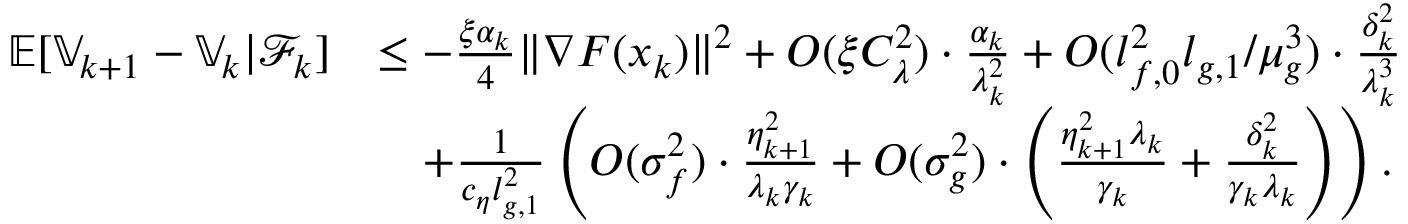<formula> <loc_0><loc_0><loc_500><loc_500>\begin{array} { r l } { \mathbb { E } [ \mathbb { V } _ { k + 1 } - \mathbb { V } _ { k } | \mathcal { F } _ { k } ] } & { \leq - \frac { \xi \alpha _ { k } } { 4 } \| \nabla F ( x _ { k } ) \| ^ { 2 } + O ( \xi C _ { \lambda } ^ { 2 } ) \cdot \frac { \alpha _ { k } } { \lambda _ { k } ^ { 2 } } + O ( l _ { f , 0 } ^ { 2 } l _ { g , 1 } / \mu _ { g } ^ { 3 } ) \cdot \frac { \delta _ { k } ^ { 2 } } { \lambda _ { k } ^ { 3 } } } \\ & { \quad + \frac { 1 } { c _ { \eta } l _ { g , 1 } ^ { 2 } } \left ( O ( \sigma _ { f } ^ { 2 } ) \cdot \frac { \eta _ { k + 1 } ^ { 2 } } { \lambda _ { k } \gamma _ { k } } + O ( \sigma _ { g } ^ { 2 } ) \cdot \left ( \frac { \eta _ { k + 1 } ^ { 2 } \lambda _ { k } } { \gamma _ { k } } + \frac { \delta _ { k } ^ { 2 } } { \gamma _ { k } \lambda _ { k } } \right ) \right ) . } \end{array}</formula> 